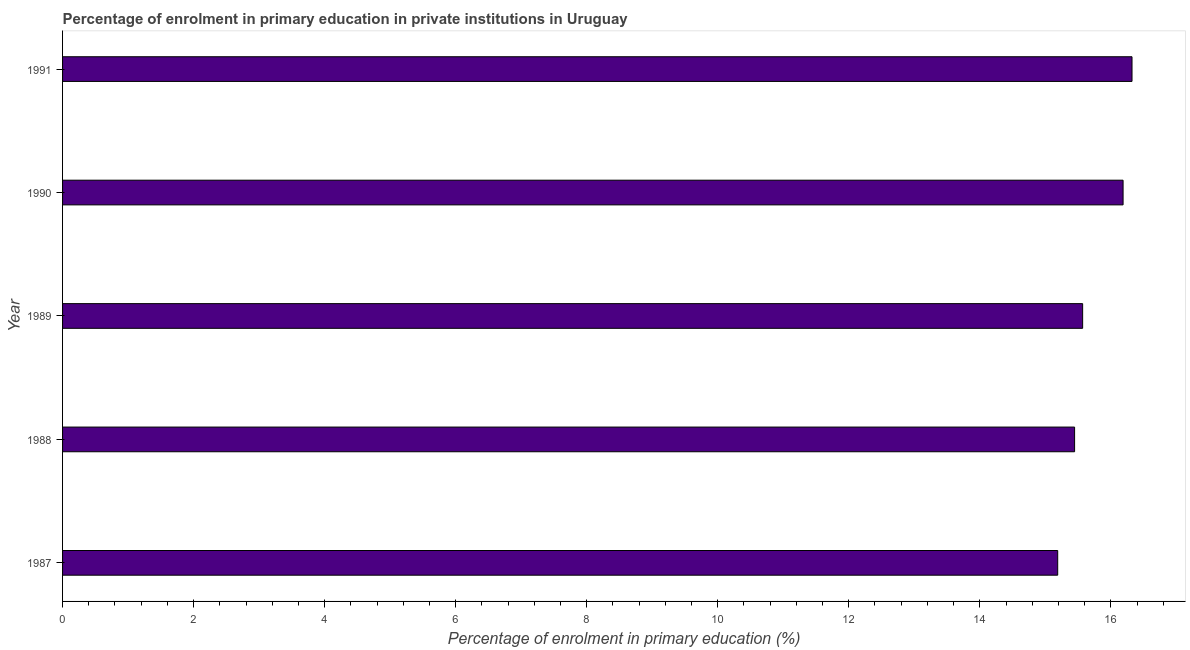Does the graph contain any zero values?
Offer a very short reply. No. Does the graph contain grids?
Keep it short and to the point. No. What is the title of the graph?
Offer a very short reply. Percentage of enrolment in primary education in private institutions in Uruguay. What is the label or title of the X-axis?
Offer a very short reply. Percentage of enrolment in primary education (%). What is the label or title of the Y-axis?
Your answer should be compact. Year. What is the enrolment percentage in primary education in 1991?
Provide a succinct answer. 16.32. Across all years, what is the maximum enrolment percentage in primary education?
Your response must be concise. 16.32. Across all years, what is the minimum enrolment percentage in primary education?
Offer a terse response. 15.19. What is the sum of the enrolment percentage in primary education?
Your answer should be compact. 78.71. What is the difference between the enrolment percentage in primary education in 1987 and 1989?
Your answer should be compact. -0.38. What is the average enrolment percentage in primary education per year?
Keep it short and to the point. 15.74. What is the median enrolment percentage in primary education?
Keep it short and to the point. 15.57. Do a majority of the years between 1991 and 1987 (inclusive) have enrolment percentage in primary education greater than 4.8 %?
Keep it short and to the point. Yes. Is the enrolment percentage in primary education in 1989 less than that in 1991?
Your answer should be compact. Yes. Is the difference between the enrolment percentage in primary education in 1990 and 1991 greater than the difference between any two years?
Your response must be concise. No. What is the difference between the highest and the second highest enrolment percentage in primary education?
Make the answer very short. 0.14. Is the sum of the enrolment percentage in primary education in 1987 and 1989 greater than the maximum enrolment percentage in primary education across all years?
Ensure brevity in your answer.  Yes. What is the difference between the highest and the lowest enrolment percentage in primary education?
Give a very brief answer. 1.13. In how many years, is the enrolment percentage in primary education greater than the average enrolment percentage in primary education taken over all years?
Give a very brief answer. 2. How many years are there in the graph?
Make the answer very short. 5. What is the difference between two consecutive major ticks on the X-axis?
Your response must be concise. 2. What is the Percentage of enrolment in primary education (%) of 1987?
Ensure brevity in your answer.  15.19. What is the Percentage of enrolment in primary education (%) of 1988?
Give a very brief answer. 15.45. What is the Percentage of enrolment in primary education (%) in 1989?
Make the answer very short. 15.57. What is the Percentage of enrolment in primary education (%) in 1990?
Ensure brevity in your answer.  16.19. What is the Percentage of enrolment in primary education (%) in 1991?
Provide a short and direct response. 16.32. What is the difference between the Percentage of enrolment in primary education (%) in 1987 and 1988?
Your answer should be very brief. -0.26. What is the difference between the Percentage of enrolment in primary education (%) in 1987 and 1989?
Offer a very short reply. -0.38. What is the difference between the Percentage of enrolment in primary education (%) in 1987 and 1990?
Your answer should be very brief. -1. What is the difference between the Percentage of enrolment in primary education (%) in 1987 and 1991?
Provide a succinct answer. -1.13. What is the difference between the Percentage of enrolment in primary education (%) in 1988 and 1989?
Offer a terse response. -0.12. What is the difference between the Percentage of enrolment in primary education (%) in 1988 and 1990?
Provide a succinct answer. -0.74. What is the difference between the Percentage of enrolment in primary education (%) in 1988 and 1991?
Make the answer very short. -0.88. What is the difference between the Percentage of enrolment in primary education (%) in 1989 and 1990?
Make the answer very short. -0.62. What is the difference between the Percentage of enrolment in primary education (%) in 1989 and 1991?
Your response must be concise. -0.75. What is the difference between the Percentage of enrolment in primary education (%) in 1990 and 1991?
Make the answer very short. -0.14. What is the ratio of the Percentage of enrolment in primary education (%) in 1987 to that in 1990?
Provide a short and direct response. 0.94. What is the ratio of the Percentage of enrolment in primary education (%) in 1988 to that in 1990?
Provide a short and direct response. 0.95. What is the ratio of the Percentage of enrolment in primary education (%) in 1988 to that in 1991?
Your answer should be compact. 0.95. What is the ratio of the Percentage of enrolment in primary education (%) in 1989 to that in 1991?
Keep it short and to the point. 0.95. 